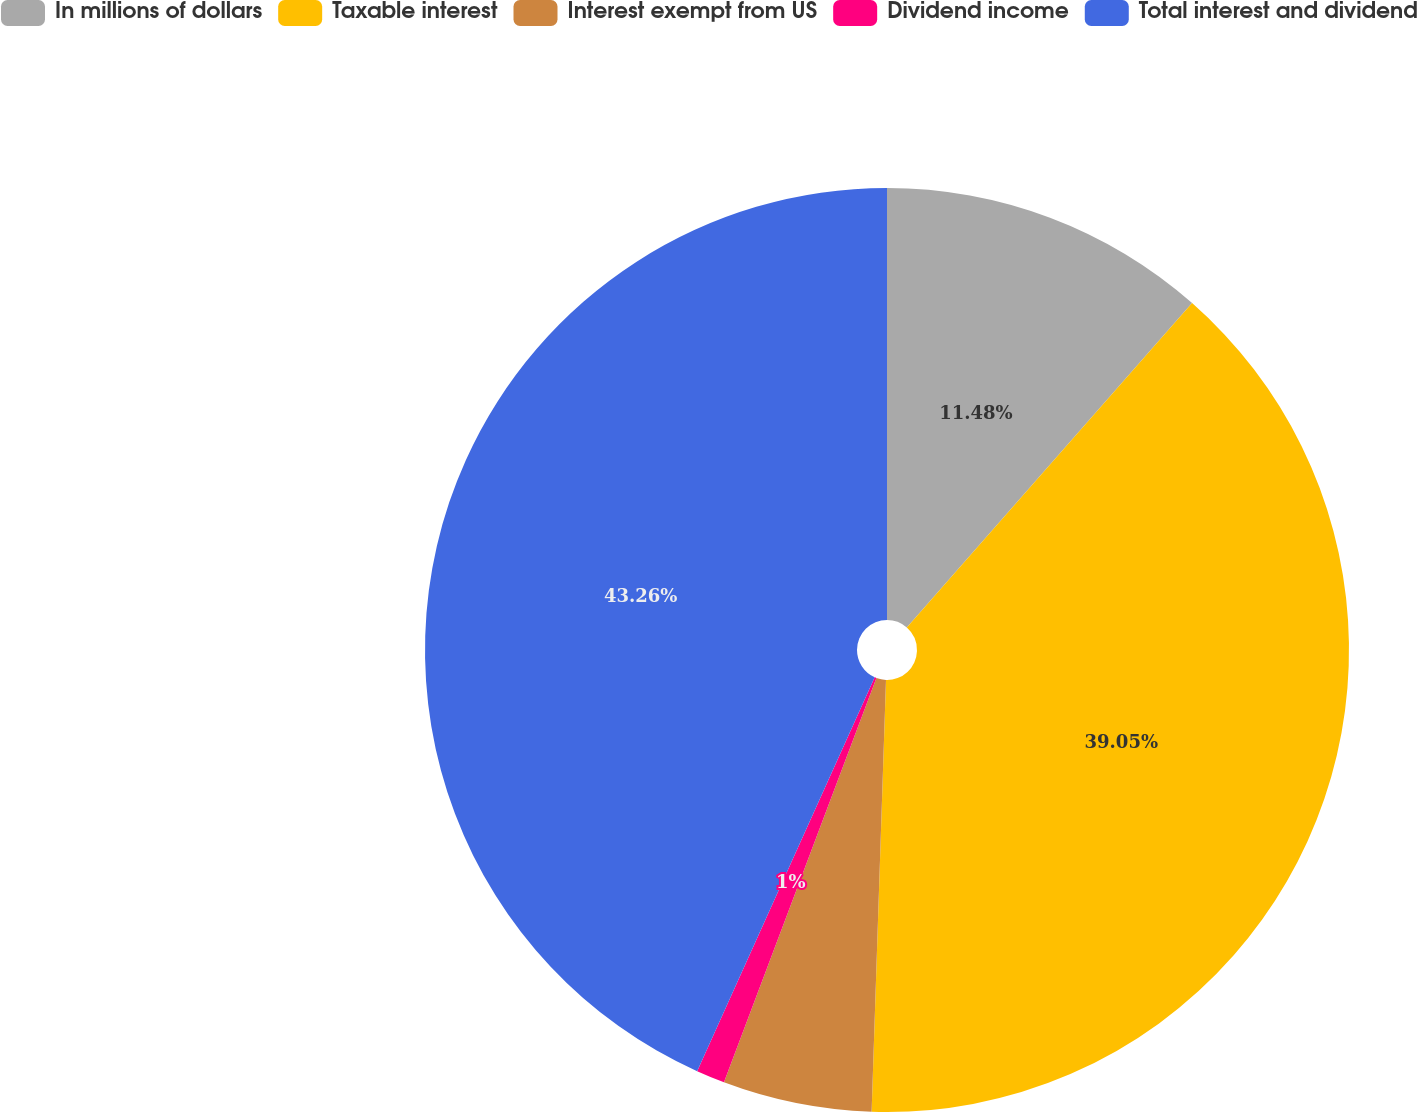<chart> <loc_0><loc_0><loc_500><loc_500><pie_chart><fcel>In millions of dollars<fcel>Taxable interest<fcel>Interest exempt from US<fcel>Dividend income<fcel>Total interest and dividend<nl><fcel>11.48%<fcel>39.05%<fcel>5.21%<fcel>1.0%<fcel>43.26%<nl></chart> 